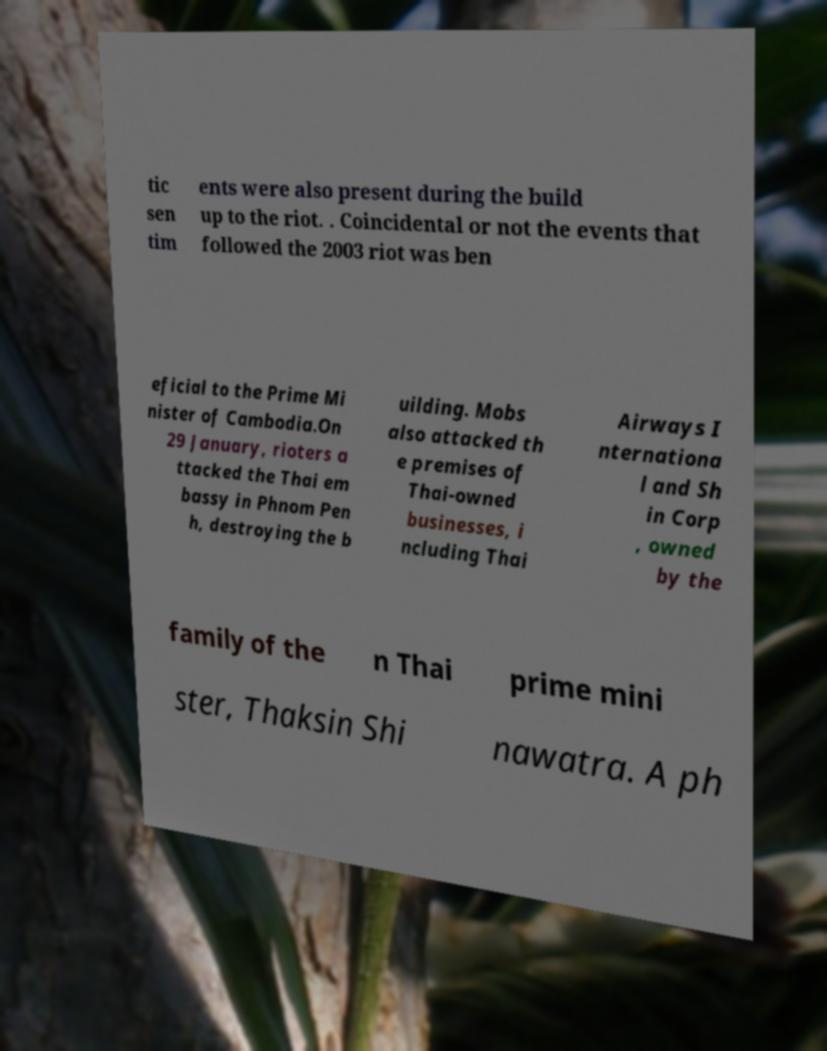There's text embedded in this image that I need extracted. Can you transcribe it verbatim? tic sen tim ents were also present during the build up to the riot. . Coincidental or not the events that followed the 2003 riot was ben eficial to the Prime Mi nister of Cambodia.On 29 January, rioters a ttacked the Thai em bassy in Phnom Pen h, destroying the b uilding. Mobs also attacked th e premises of Thai-owned businesses, i ncluding Thai Airways I nternationa l and Sh in Corp , owned by the family of the n Thai prime mini ster, Thaksin Shi nawatra. A ph 